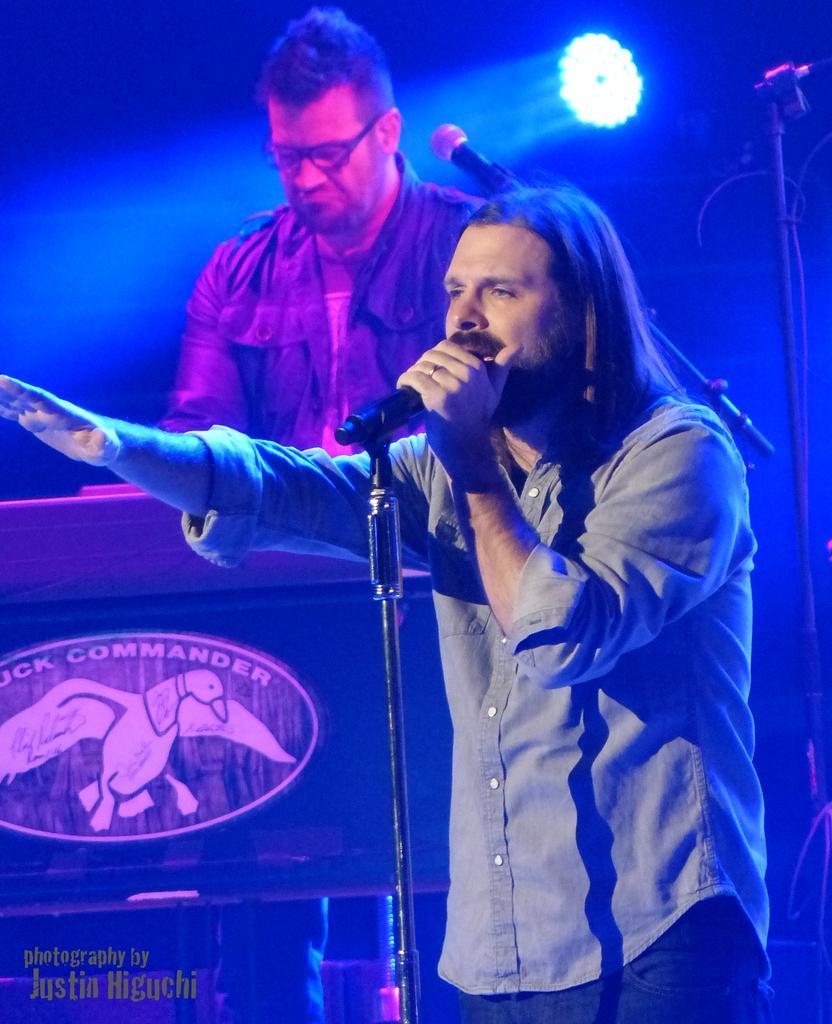In one or two sentences, can you explain what this image depicts? In this picture, we can see two persons, among them a person is holding a microphone, we can see some microphones, and table with poster attached to it, we can see the dark background with blue light. 